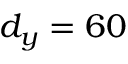<formula> <loc_0><loc_0><loc_500><loc_500>d _ { y } = 6 0</formula> 